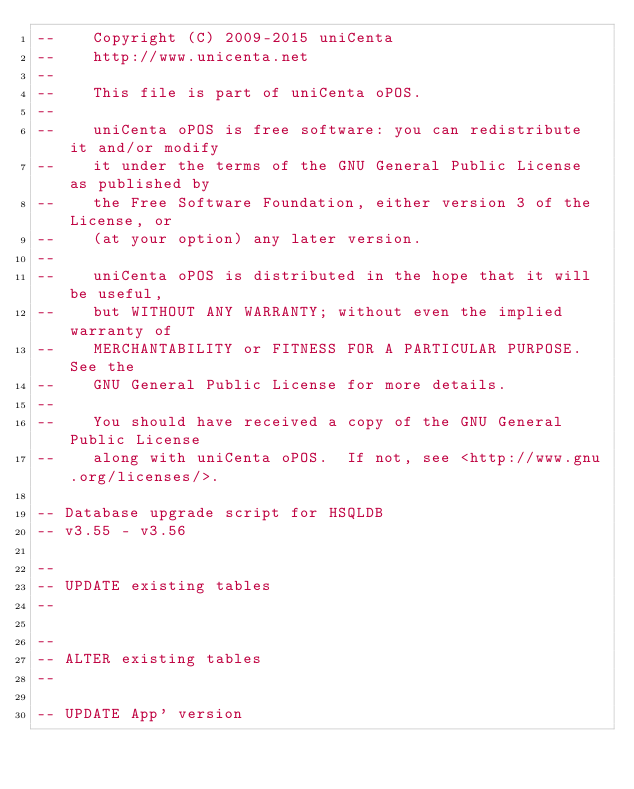Convert code to text. <code><loc_0><loc_0><loc_500><loc_500><_SQL_>--    Copyright (C) 2009-2015 uniCenta
--    http://www.unicenta.net
--
--    This file is part of uniCenta oPOS.
--
--    uniCenta oPOS is free software: you can redistribute it and/or modify
--    it under the terms of the GNU General Public License as published by
--    the Free Software Foundation, either version 3 of the License, or
--    (at your option) any later version.
--
--    uniCenta oPOS is distributed in the hope that it will be useful,
--    but WITHOUT ANY WARRANTY; without even the implied warranty of
--    MERCHANTABILITY or FITNESS FOR A PARTICULAR PURPOSE.  See the
--    GNU General Public License for more details.
--
--    You should have received a copy of the GNU General Public License
--    along with uniCenta oPOS.  If not, see <http://www.gnu.org/licenses/>.

-- Database upgrade script for HSQLDB
-- v3.55 - v3.56

--
-- UPDATE existing tables
--

--
-- ALTER existing tables
--

-- UPDATE App' version</code> 